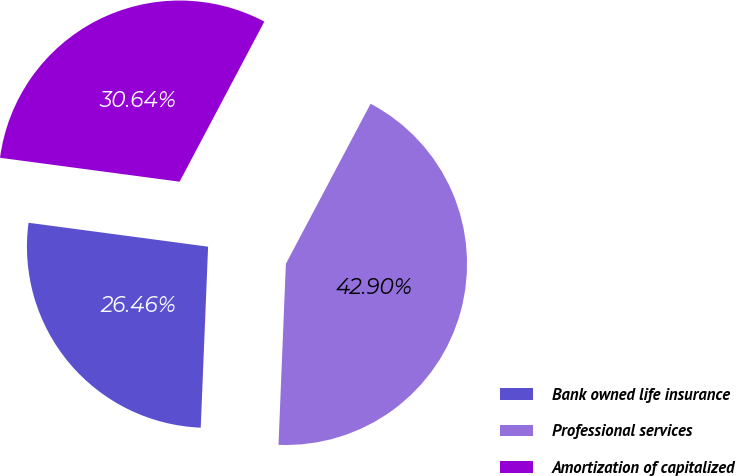Convert chart to OTSL. <chart><loc_0><loc_0><loc_500><loc_500><pie_chart><fcel>Bank owned life insurance<fcel>Professional services<fcel>Amortization of capitalized<nl><fcel>26.46%<fcel>42.9%<fcel>30.64%<nl></chart> 